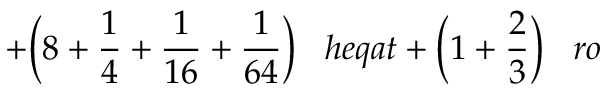<formula> <loc_0><loc_0><loc_500><loc_500>+ { \left ( } 8 + { \frac { 1 } { 4 } } + { \frac { 1 } { 1 6 } } + { \frac { 1 } { 6 4 } } { \right ) } \, h e q a t + { \left ( } 1 + { \frac { 2 } { 3 } } { \right ) } \, r o</formula> 